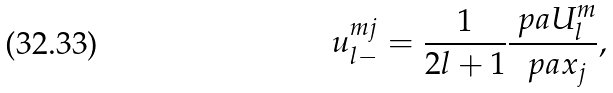<formula> <loc_0><loc_0><loc_500><loc_500>u _ { l - } ^ { m j } = \frac { 1 } { 2 l + 1 } \frac { \ p a U _ { l } ^ { m } } { \ p a x _ { j } } ,</formula> 